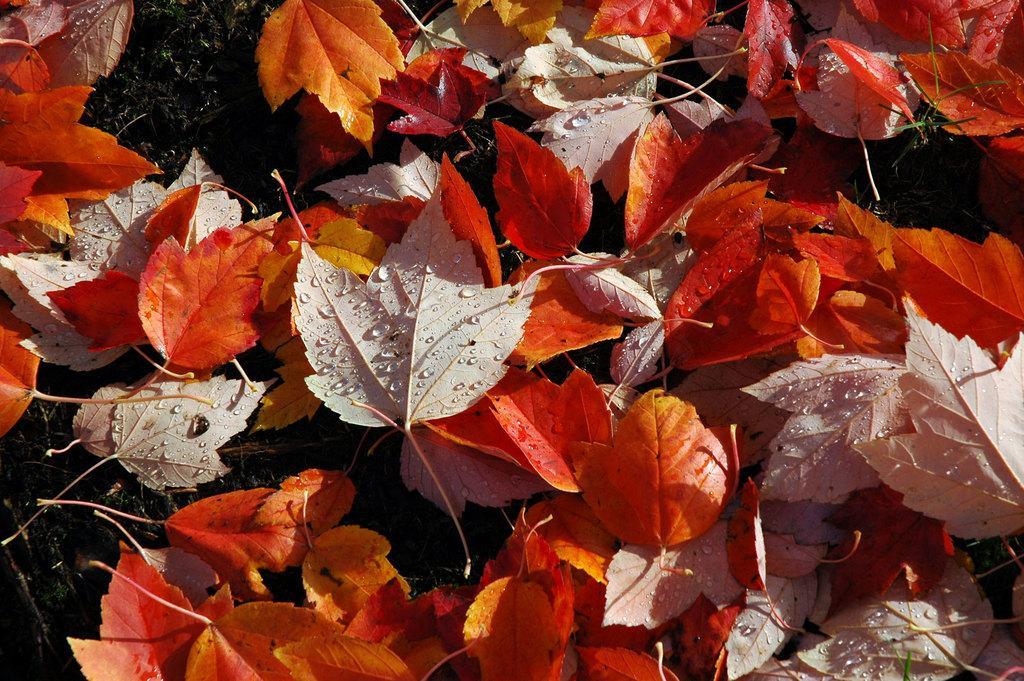In one or two sentences, can you explain what this image depicts? These are the autumn leaves, which are lying on the ground. This is the grass. I can see water drops on the leaves. 